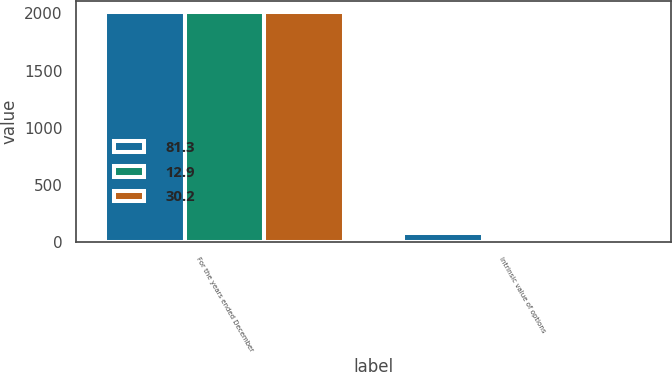Convert chart. <chart><loc_0><loc_0><loc_500><loc_500><stacked_bar_chart><ecel><fcel>For the years ended December<fcel>Intrinsic value of options<nl><fcel>81.3<fcel>2011<fcel>81.3<nl><fcel>12.9<fcel>2010<fcel>30.2<nl><fcel>30.2<fcel>2009<fcel>12.9<nl></chart> 